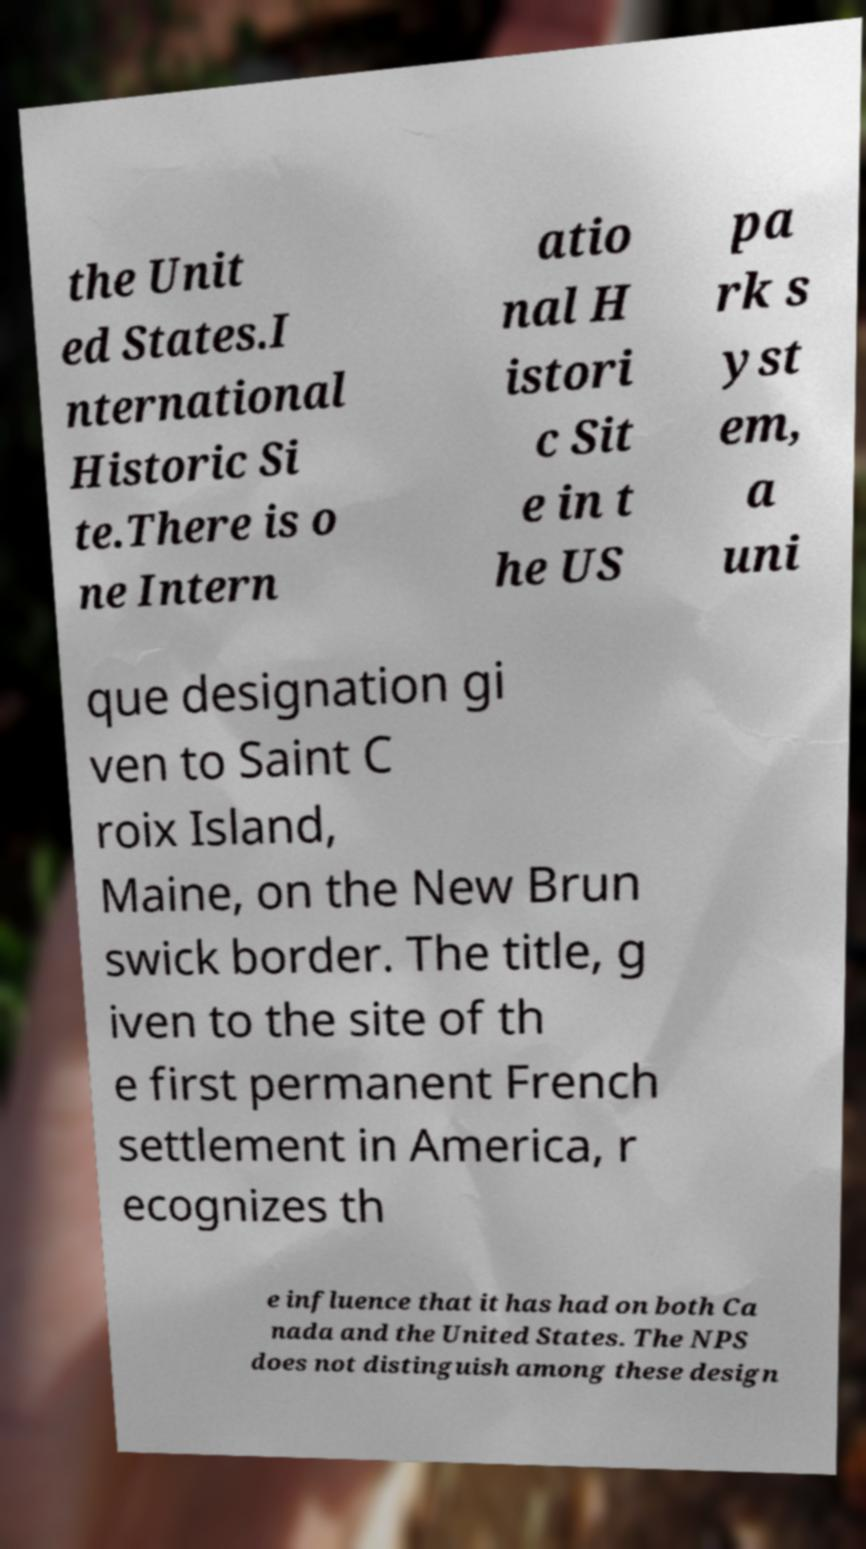There's text embedded in this image that I need extracted. Can you transcribe it verbatim? the Unit ed States.I nternational Historic Si te.There is o ne Intern atio nal H istori c Sit e in t he US pa rk s yst em, a uni que designation gi ven to Saint C roix Island, Maine, on the New Brun swick border. The title, g iven to the site of th e first permanent French settlement in America, r ecognizes th e influence that it has had on both Ca nada and the United States. The NPS does not distinguish among these design 